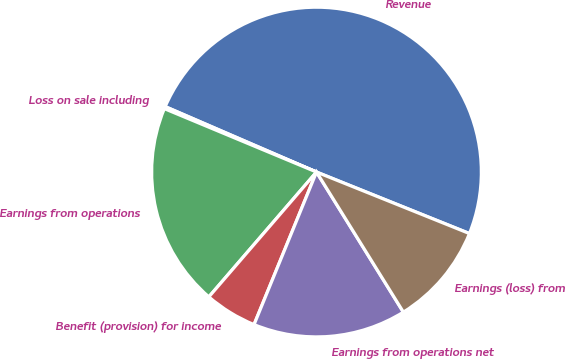Convert chart. <chart><loc_0><loc_0><loc_500><loc_500><pie_chart><fcel>Revenue<fcel>Loss on sale including<fcel>Earnings from operations<fcel>Benefit (provision) for income<fcel>Earnings from operations net<fcel>Earnings (loss) from<nl><fcel>49.59%<fcel>0.21%<fcel>19.96%<fcel>5.14%<fcel>15.02%<fcel>10.08%<nl></chart> 